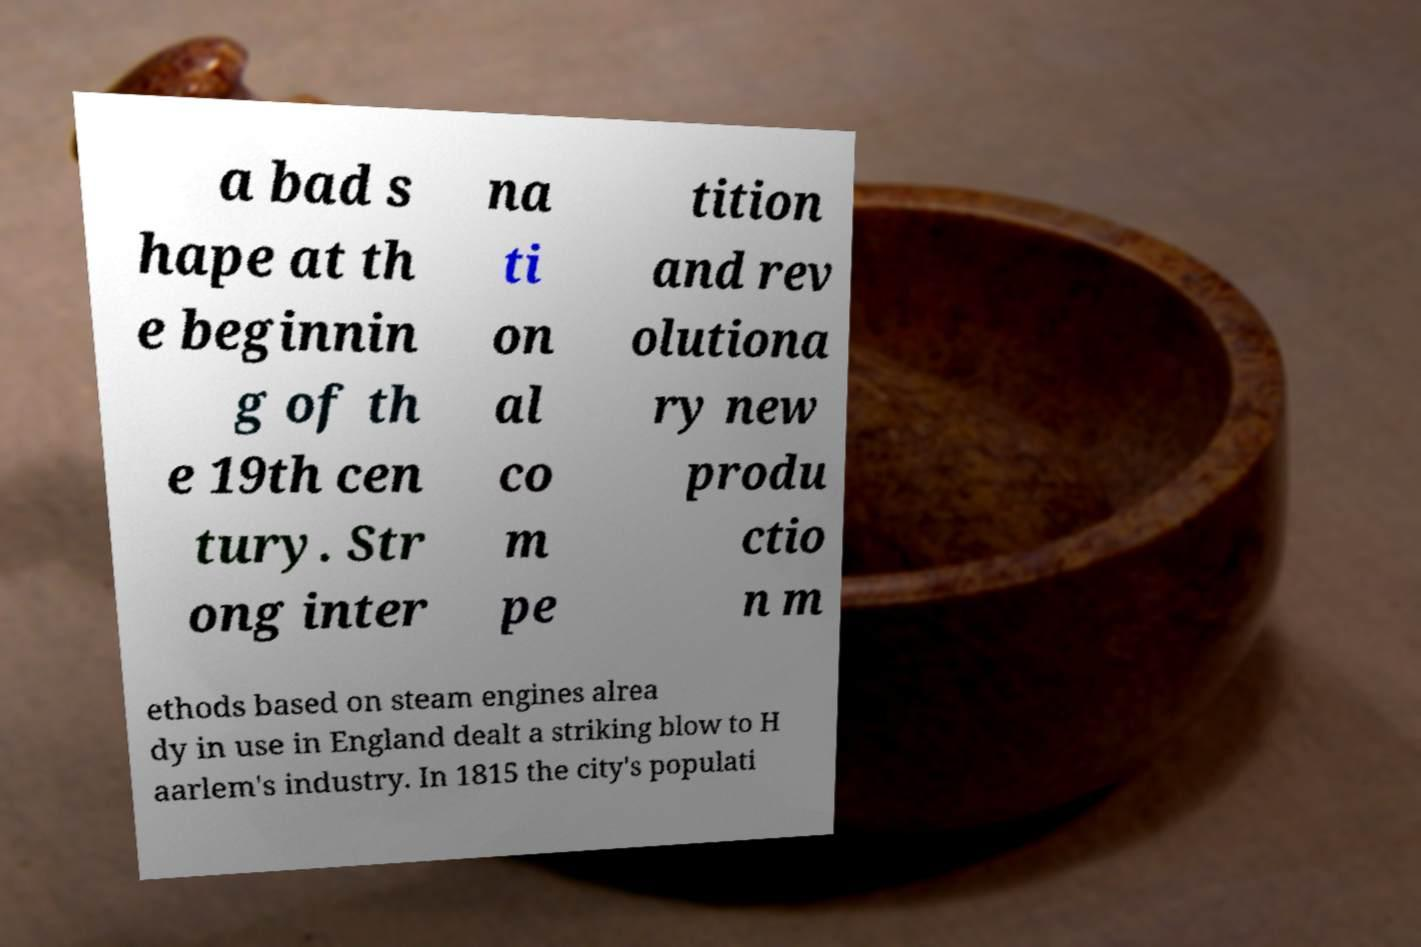Can you read and provide the text displayed in the image?This photo seems to have some interesting text. Can you extract and type it out for me? a bad s hape at th e beginnin g of th e 19th cen tury. Str ong inter na ti on al co m pe tition and rev olutiona ry new produ ctio n m ethods based on steam engines alrea dy in use in England dealt a striking blow to H aarlem's industry. In 1815 the city's populati 